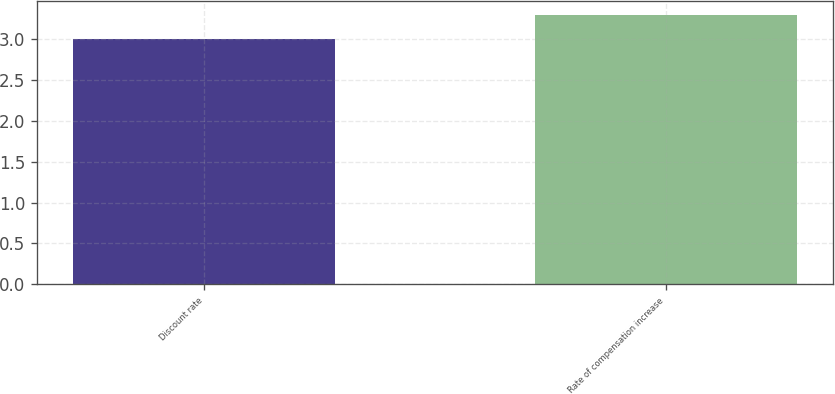Convert chart. <chart><loc_0><loc_0><loc_500><loc_500><bar_chart><fcel>Discount rate<fcel>Rate of compensation increase<nl><fcel>3<fcel>3.3<nl></chart> 